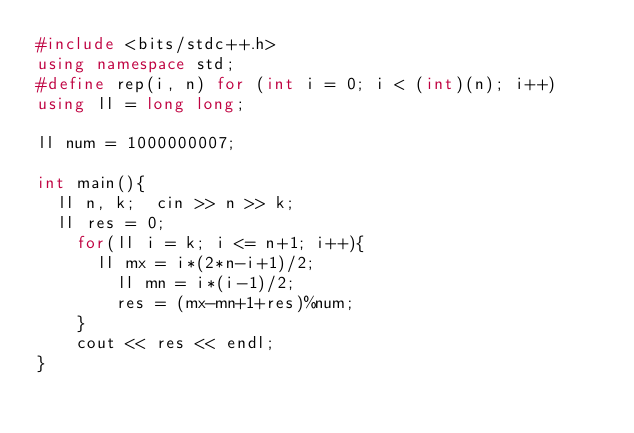<code> <loc_0><loc_0><loc_500><loc_500><_C++_>#include <bits/stdc++.h>
using namespace std;
#define rep(i, n) for (int i = 0; i < (int)(n); i++)
using ll = long long;

ll num = 1000000007;

int main(){
	ll n, k;	cin >> n >> k;
	ll res = 0;
  	for(ll i = k; i <= n+1; i++){
    	ll mx = i*(2*n-i+1)/2;
      	ll mn = i*(i-1)/2;
      	res = (mx-mn+1+res)%num;
    }
  	cout << res << endl;
} </code> 